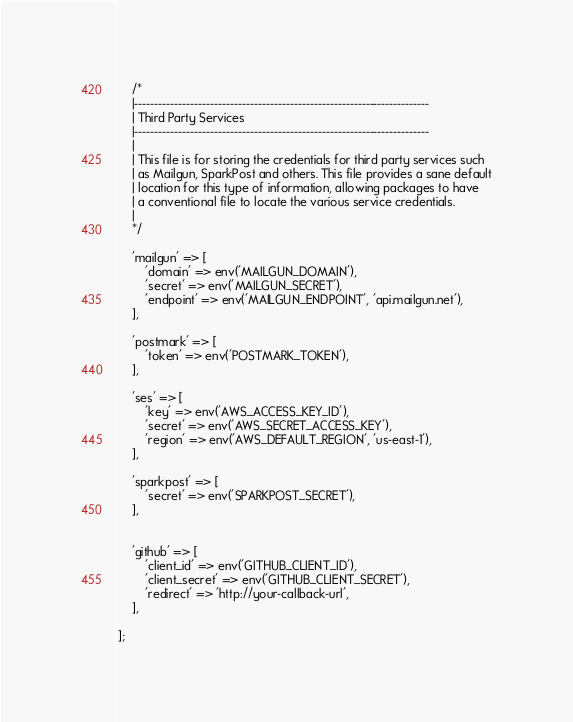Convert code to text. <code><loc_0><loc_0><loc_500><loc_500><_PHP_>
    /*
    |--------------------------------------------------------------------------
    | Third Party Services
    |--------------------------------------------------------------------------
    |
    | This file is for storing the credentials for third party services such
    | as Mailgun, SparkPost and others. This file provides a sane default
    | location for this type of information, allowing packages to have
    | a conventional file to locate the various service credentials.
    |
    */

    'mailgun' => [
        'domain' => env('MAILGUN_DOMAIN'),
        'secret' => env('MAILGUN_SECRET'),
        'endpoint' => env('MAILGUN_ENDPOINT', 'api.mailgun.net'),
    ],

    'postmark' => [
        'token' => env('POSTMARK_TOKEN'),
    ],

    'ses' => [
        'key' => env('AWS_ACCESS_KEY_ID'),
        'secret' => env('AWS_SECRET_ACCESS_KEY'),
        'region' => env('AWS_DEFAULT_REGION', 'us-east-1'),
    ],

    'sparkpost' => [
        'secret' => env('SPARKPOST_SECRET'),
    ],


    'github' => [
        'client_id' => env('GITHUB_CLIENT_ID'),
        'client_secret' => env('GITHUB_CLIENT_SECRET'),
        'redirect' => 'http://your-callback-url',
    ],

];
</code> 